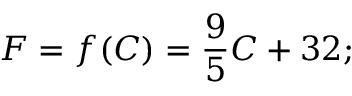<formula> <loc_0><loc_0><loc_500><loc_500>F = f ( C ) = { \frac { 9 } { 5 } } C + 3 2 ;</formula> 